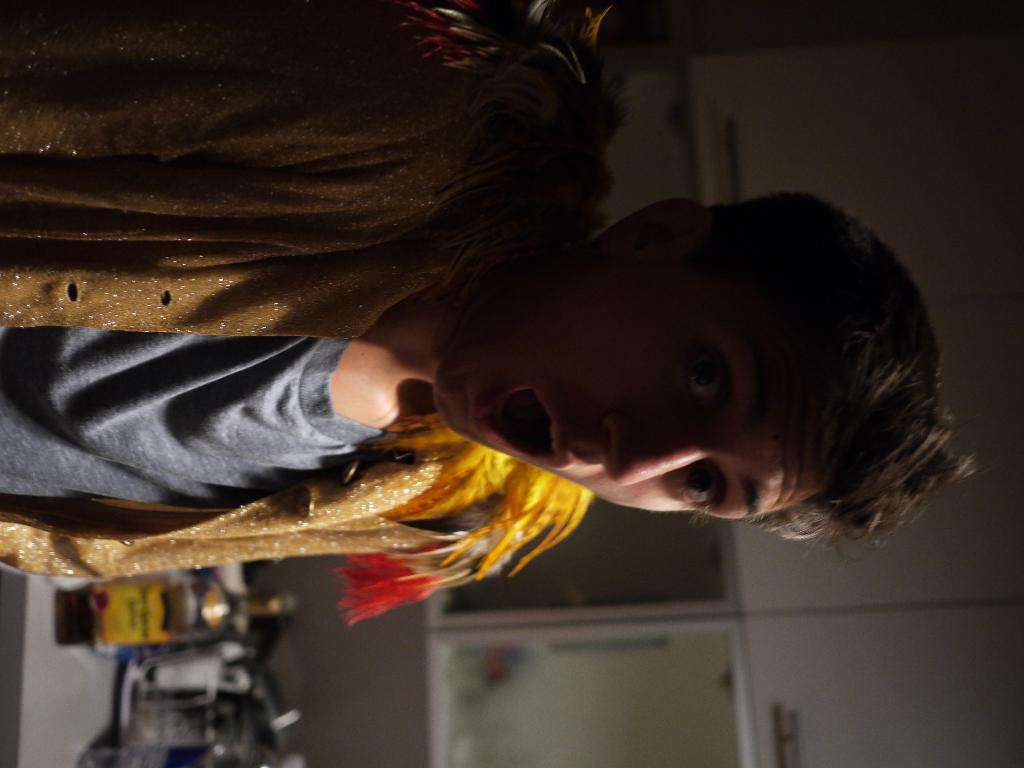What is the man in the image wearing? The man is wearing a costume in the image. How would you describe the background of the image? The background of the image is blurry. What can be seen next to the man in the image? There is a bottle visible in the image. What is the man standing on or near in the image? There are objects on a platform in the image. What type of structure is present in the image? There is a wall in the image. What type of hydrant is present in the image? There is no hydrant present in the image. What type of jeans is the man wearing in the image? The man is wearing a costume, not jeans, in the image. 